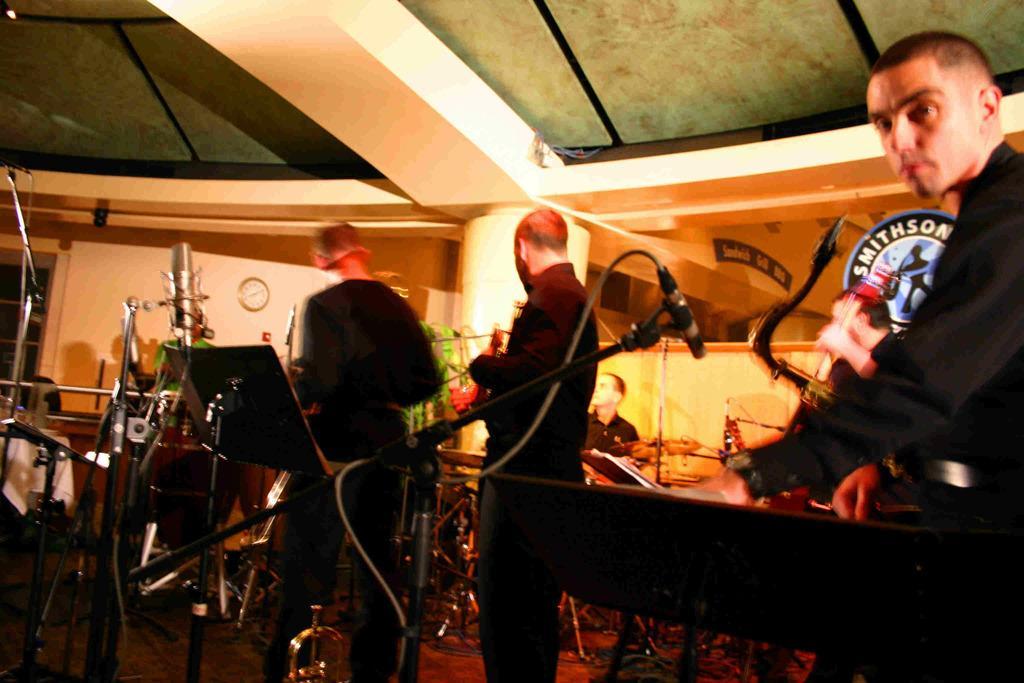How would you summarize this image in a sentence or two? As we can see in the image there is a wall, clock, mic and few people here and there. 